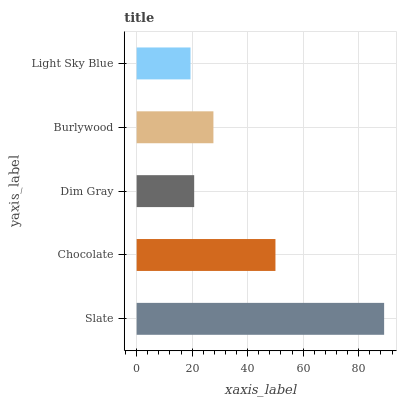Is Light Sky Blue the minimum?
Answer yes or no. Yes. Is Slate the maximum?
Answer yes or no. Yes. Is Chocolate the minimum?
Answer yes or no. No. Is Chocolate the maximum?
Answer yes or no. No. Is Slate greater than Chocolate?
Answer yes or no. Yes. Is Chocolate less than Slate?
Answer yes or no. Yes. Is Chocolate greater than Slate?
Answer yes or no. No. Is Slate less than Chocolate?
Answer yes or no. No. Is Burlywood the high median?
Answer yes or no. Yes. Is Burlywood the low median?
Answer yes or no. Yes. Is Light Sky Blue the high median?
Answer yes or no. No. Is Slate the low median?
Answer yes or no. No. 